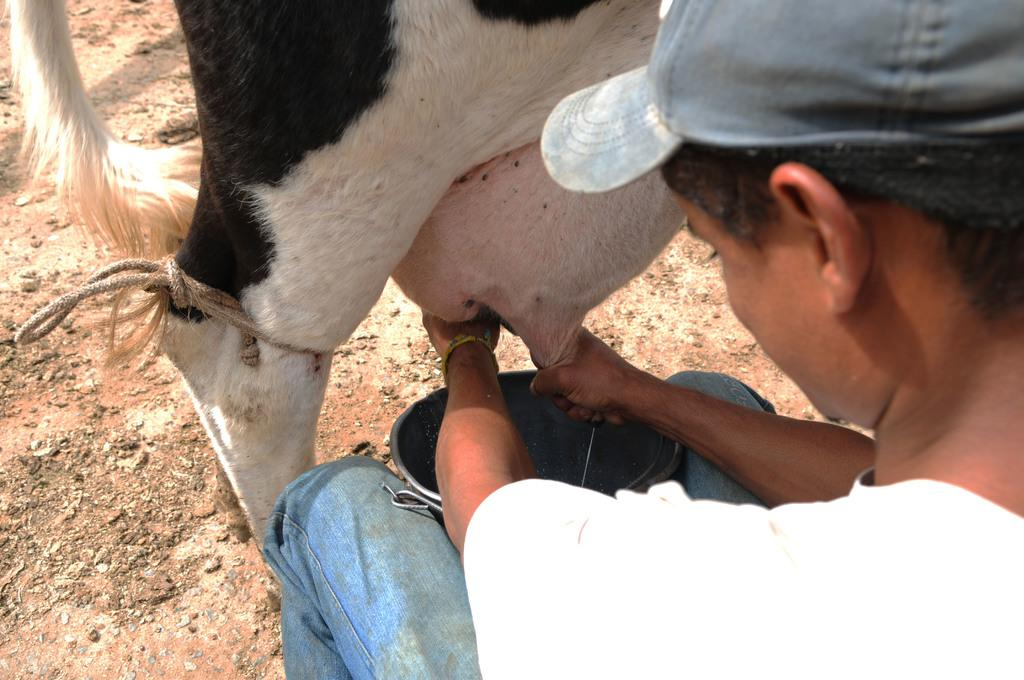Who is the person in the image? There is a man in the image. What is the man doing in the image? The man is milking a cow. How is the cow being milked? The cow is being milked by hand. What is the purpose of the bucket in the image? The bucket is likely being used to collect the milk from the cow. What type of island can be seen in the background of the image? There is no island visible in the image; it features a man milking a cow. Can you describe the space suit the man is wearing while milking the cow? The man is not wearing a space suit in the image; he is dressed in regular clothing. 